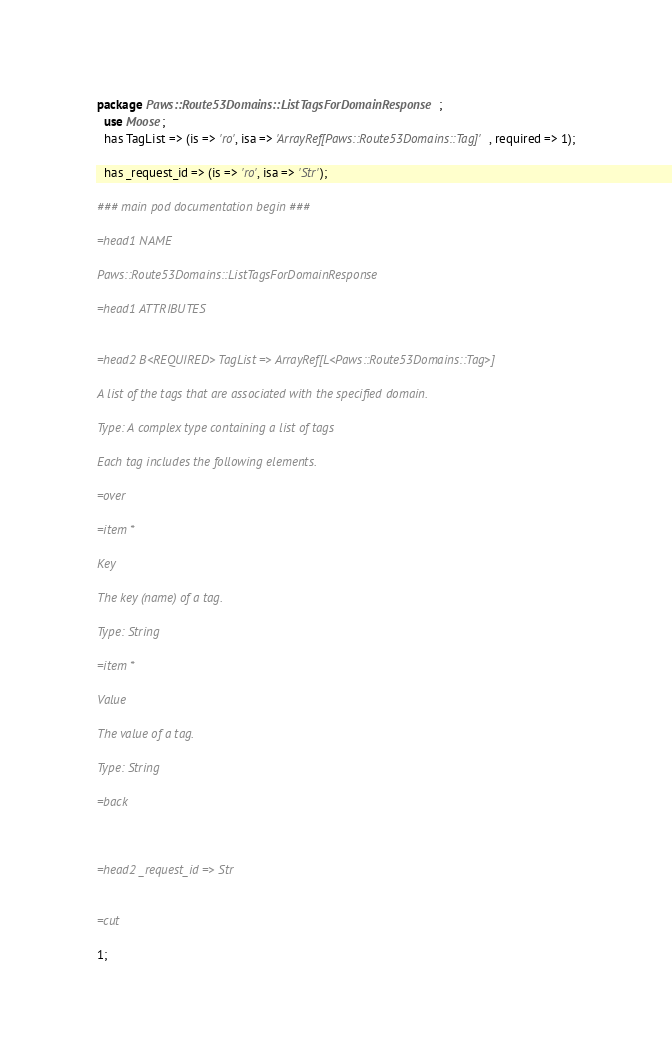Convert code to text. <code><loc_0><loc_0><loc_500><loc_500><_Perl_>
package Paws::Route53Domains::ListTagsForDomainResponse;
  use Moose;
  has TagList => (is => 'ro', isa => 'ArrayRef[Paws::Route53Domains::Tag]', required => 1);

  has _request_id => (is => 'ro', isa => 'Str');

### main pod documentation begin ###

=head1 NAME

Paws::Route53Domains::ListTagsForDomainResponse

=head1 ATTRIBUTES


=head2 B<REQUIRED> TagList => ArrayRef[L<Paws::Route53Domains::Tag>]

A list of the tags that are associated with the specified domain.

Type: A complex type containing a list of tags

Each tag includes the following elements.

=over

=item *

Key

The key (name) of a tag.

Type: String

=item *

Value

The value of a tag.

Type: String

=back



=head2 _request_id => Str


=cut

1;</code> 